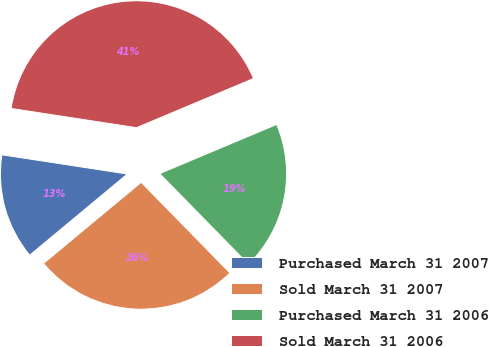<chart> <loc_0><loc_0><loc_500><loc_500><pie_chart><fcel>Purchased March 31 2007<fcel>Sold March 31 2007<fcel>Purchased March 31 2006<fcel>Sold March 31 2006<nl><fcel>13.46%<fcel>26.3%<fcel>19.0%<fcel>41.25%<nl></chart> 